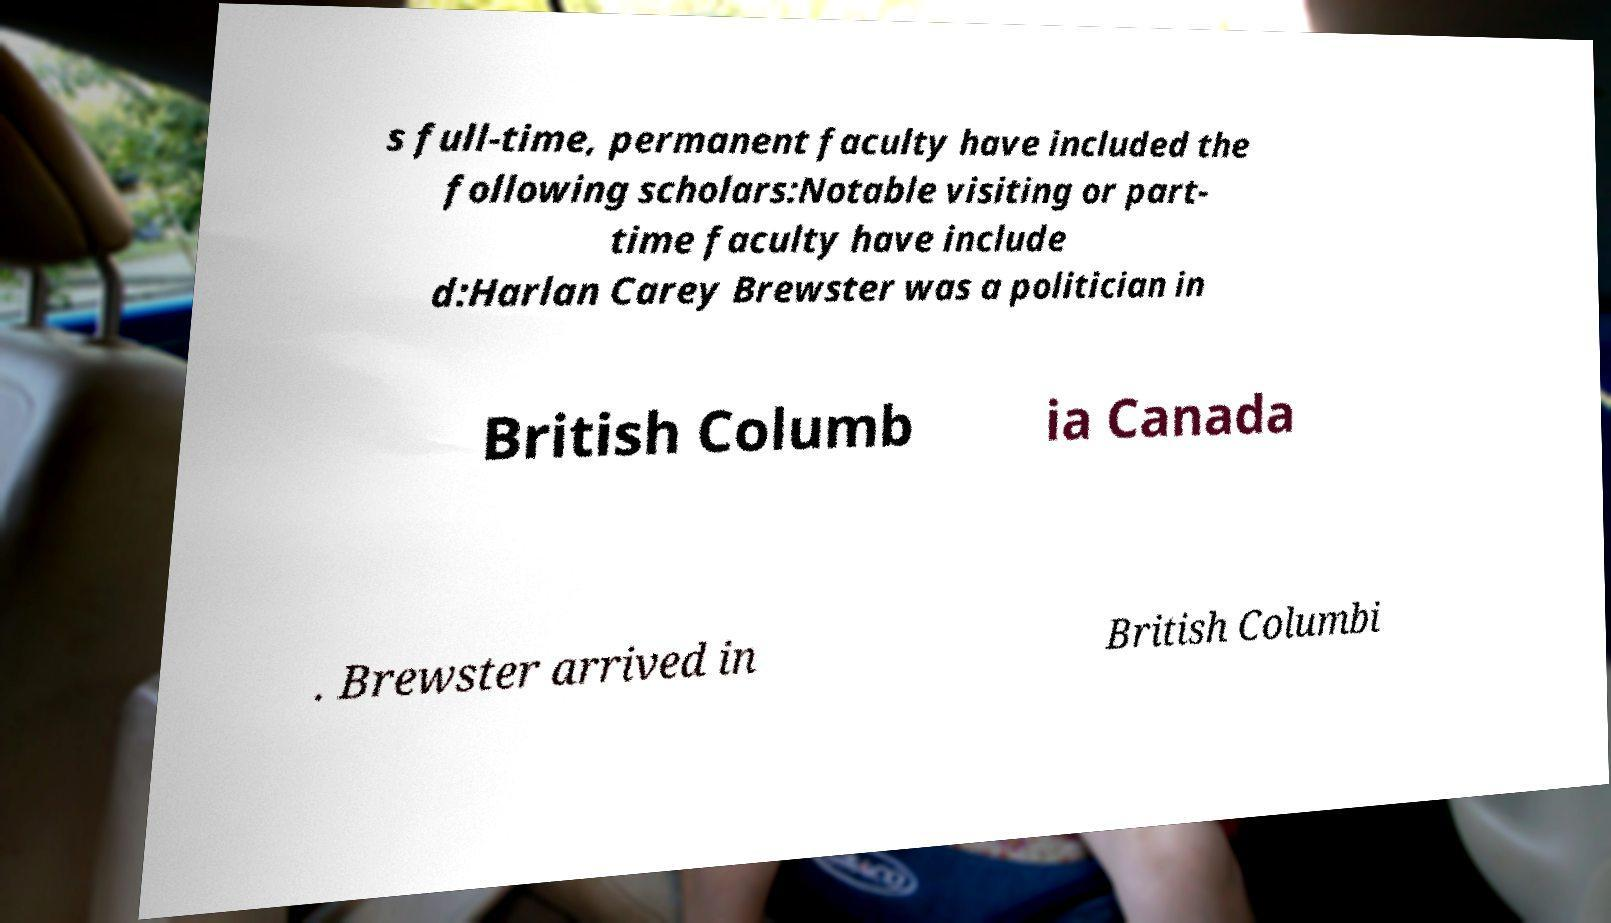What messages or text are displayed in this image? I need them in a readable, typed format. s full-time, permanent faculty have included the following scholars:Notable visiting or part- time faculty have include d:Harlan Carey Brewster was a politician in British Columb ia Canada . Brewster arrived in British Columbi 